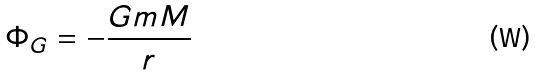Convert formula to latex. <formula><loc_0><loc_0><loc_500><loc_500>\Phi _ { G } = - \frac { G m M } { r }</formula> 